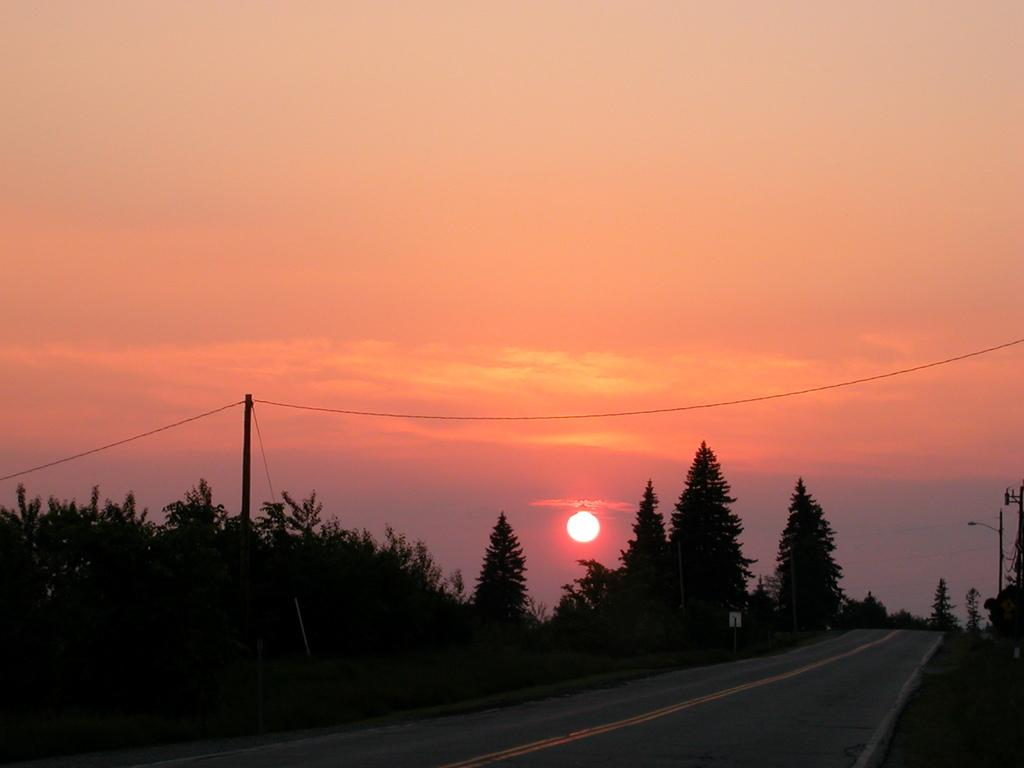What type of pathway is present in the image? There is a road in the image. What natural elements can be seen in the image? There are trees in the image. What man-made object is present in the image? There is a pole in the image. What celestial body is visible in the image? The sun is visible in the image. What part of the natural environment is visible in the image? The sky is visible in the image. Can you see any toes in the image? There are no toes present in the image. What type of rod is being used to measure the height of the trees in the image? There is no rod present in the image, and the height of the trees is not being measured. 